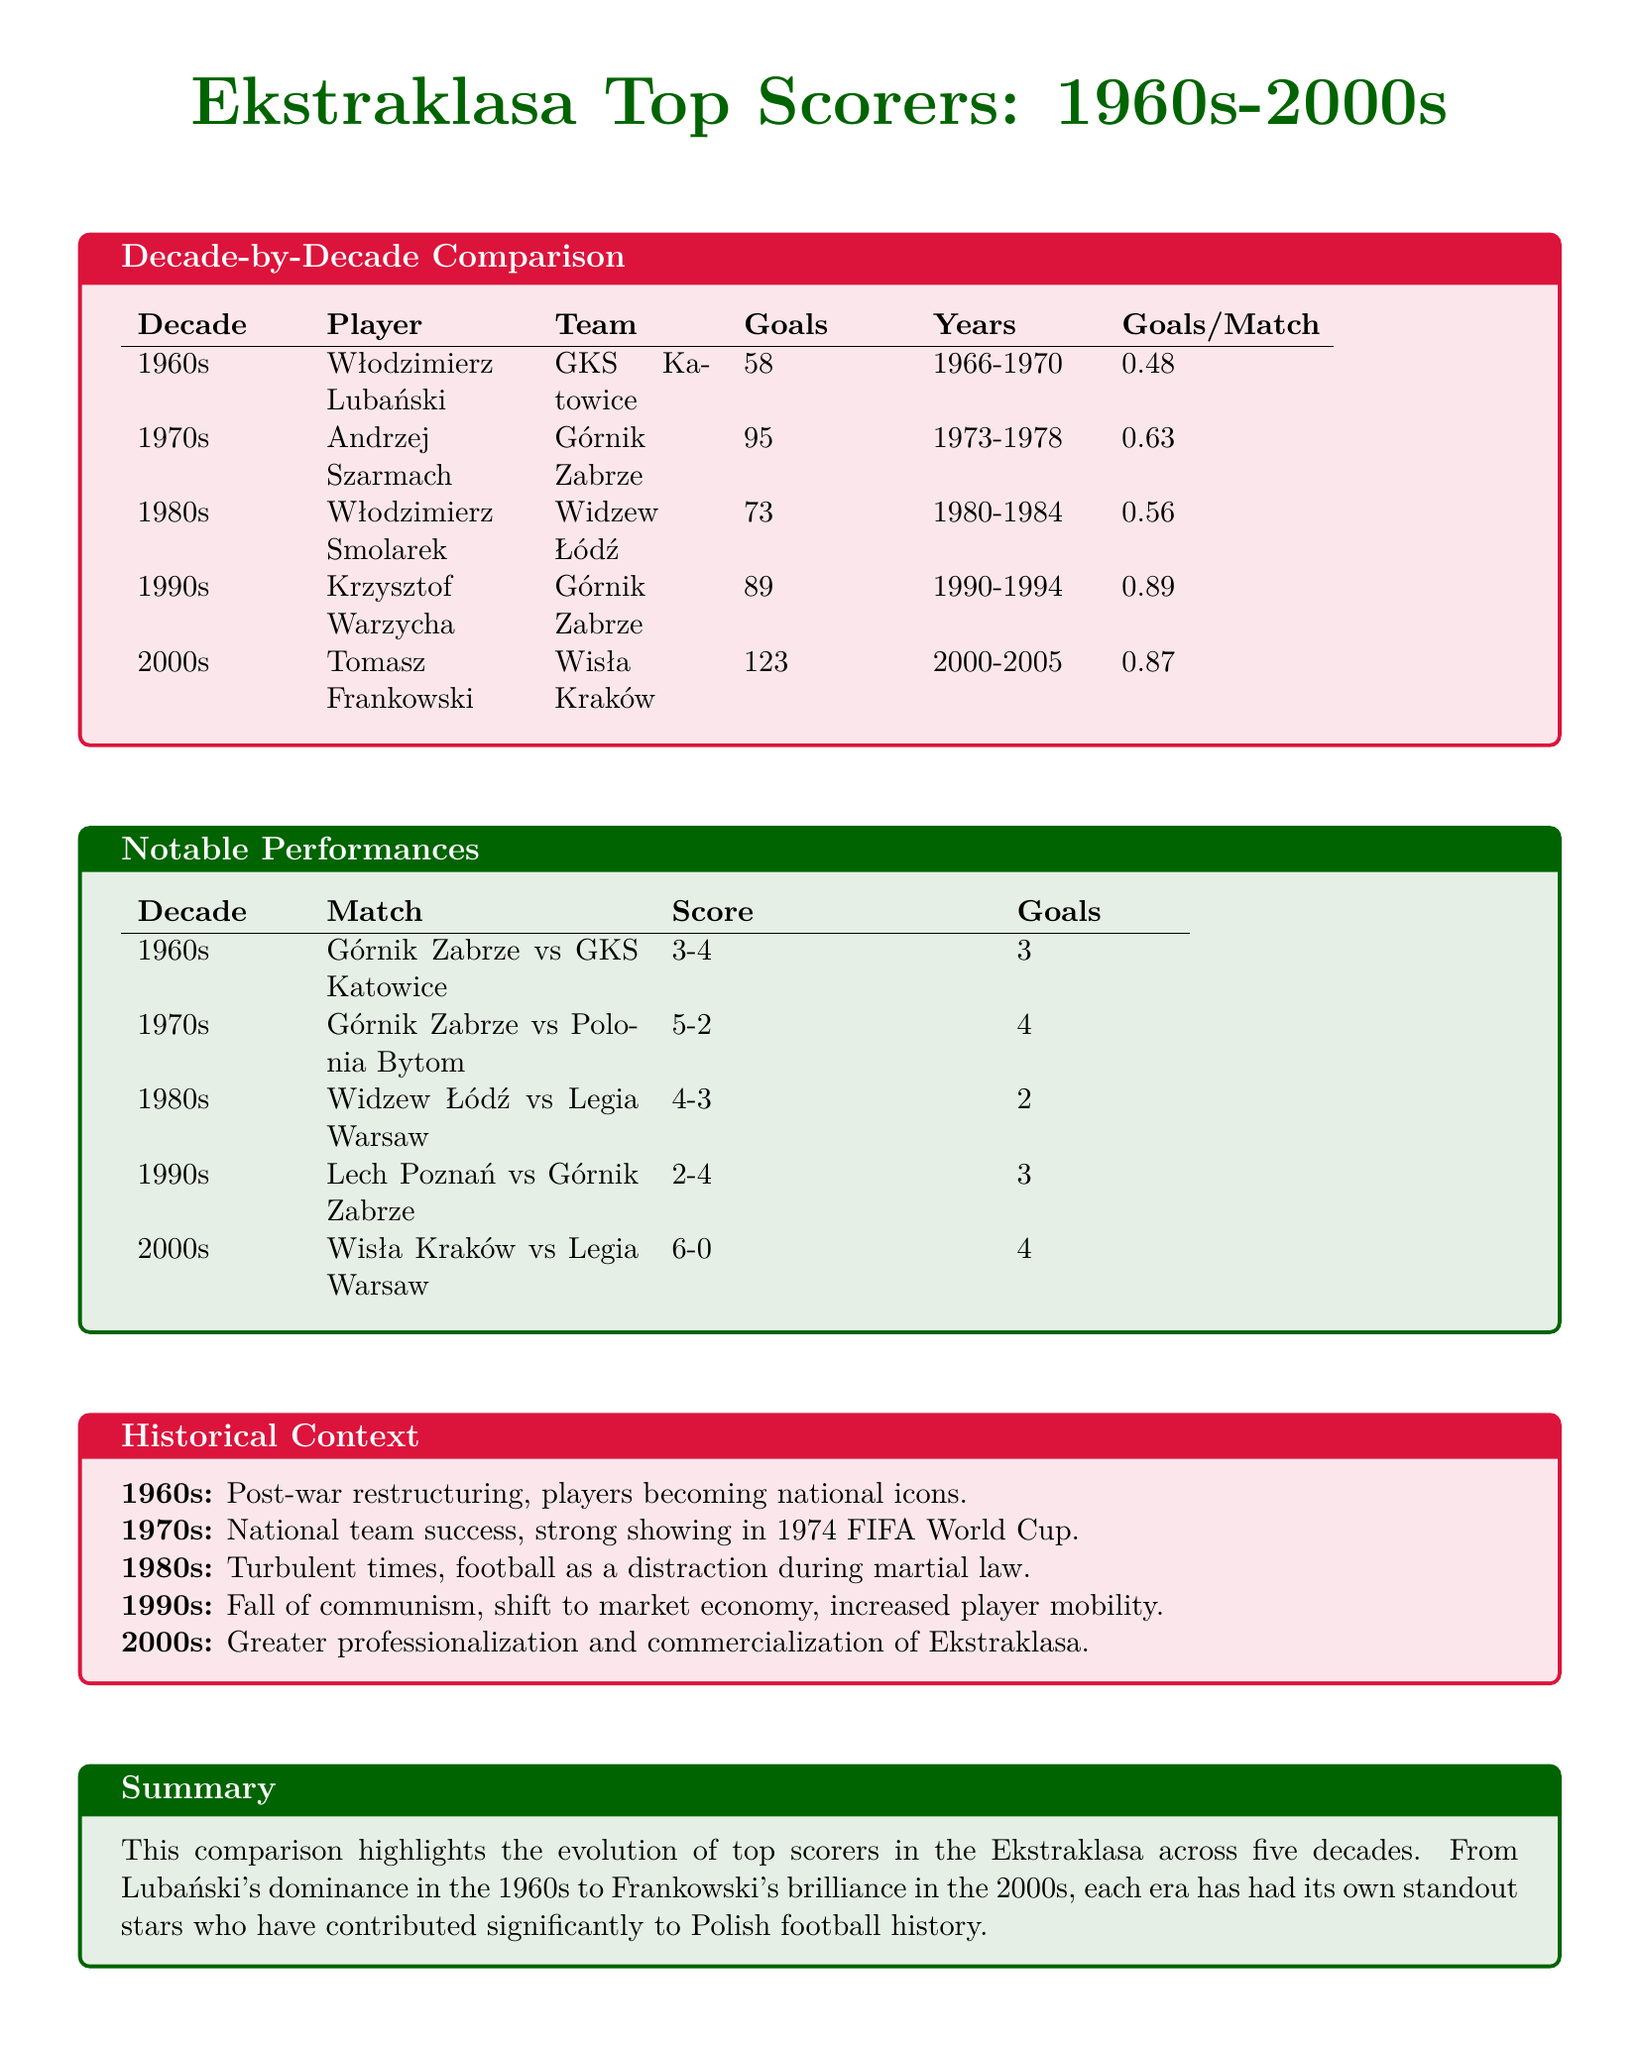What was the top score in the 2000s? The top score in the 2000s was achieved by Tomasz Frankowski, who scored 123 goals.
Answer: 123 Who scored the most goals in the 1970s? The most goals in the 1970s were scored by Andrzej Szarmach, with 95 goals.
Answer: Andrzej Szarmach What was Włodzimierz Lubański's goals per match ratio? Włodzimierz Lubański had a goals per match ratio of 0.48, indicating the number of goals he scored per match played.
Answer: 0.48 Which decade featured notable performances by Wisła Kraków? Notable performances by Wisła Kraków were highlighted in the 2000s, specifically in a match where they scored 6 goals against Legia Warsaw.
Answer: 2000s What is the historical significance of the 1990s in Polish football? The 1990s marked the fall of communism and a shift to a market economy, leading to increased player mobility and transformation in football.
Answer: Fall of communism Which player had the highest goals per match ratio and how much was it? The player with the highest goals per match ratio is Krzysztof Warzycha, with a ratio of 0.89, indicating his scoring efficiency.
Answer: 0.89 What was the score in the notable match of Widzew Łódź vs Legia Warsaw from the 1980s? In that notable match, the score was 4-3 in favor of Widzew Łódź, showcasing a close and intense game.
Answer: 4-3 How many goals did Włodzimierz Smolarek score in the 1980s? Włodzimierz Smolarek scored a total of 73 goals in the 1980s, contributing significantly to his team's success.
Answer: 73 What major event occurred in Polish football during the 1970s? The 1970s saw national team success, including a strong showing in the 1974 FIFA World Cup, marking an important era in Polish football history.
Answer: 1974 FIFA World Cup 